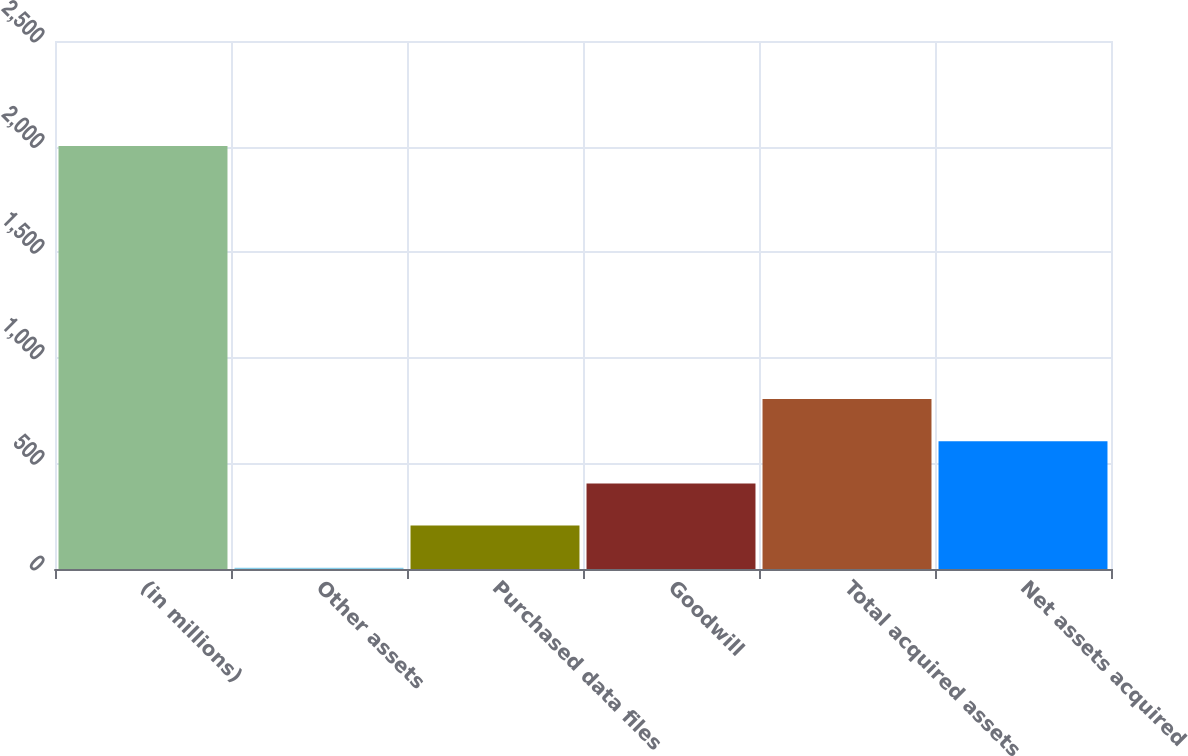Convert chart to OTSL. <chart><loc_0><loc_0><loc_500><loc_500><bar_chart><fcel>(in millions)<fcel>Other assets<fcel>Purchased data files<fcel>Goodwill<fcel>Total acquired assets<fcel>Net assets acquired<nl><fcel>2003<fcel>5.9<fcel>205.61<fcel>405.32<fcel>804.74<fcel>605.03<nl></chart> 